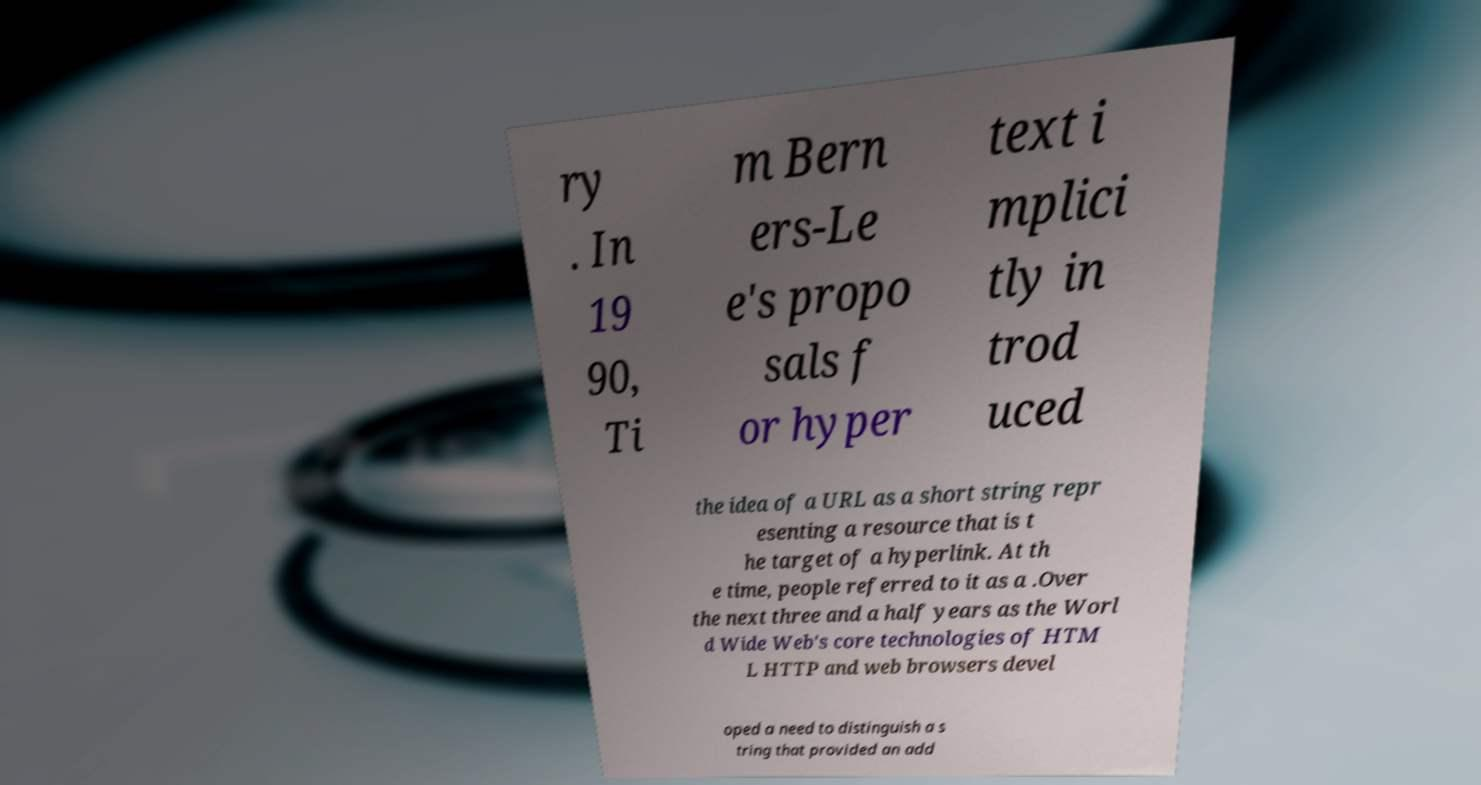Can you read and provide the text displayed in the image?This photo seems to have some interesting text. Can you extract and type it out for me? ry . In 19 90, Ti m Bern ers-Le e's propo sals f or hyper text i mplici tly in trod uced the idea of a URL as a short string repr esenting a resource that is t he target of a hyperlink. At th e time, people referred to it as a .Over the next three and a half years as the Worl d Wide Web's core technologies of HTM L HTTP and web browsers devel oped a need to distinguish a s tring that provided an add 